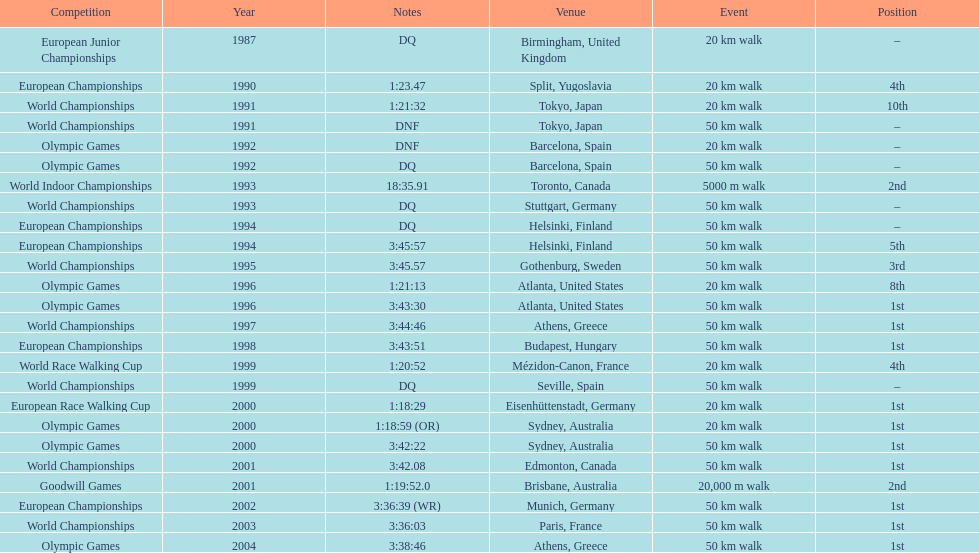Which venue is listed the most? Athens, Greece. 